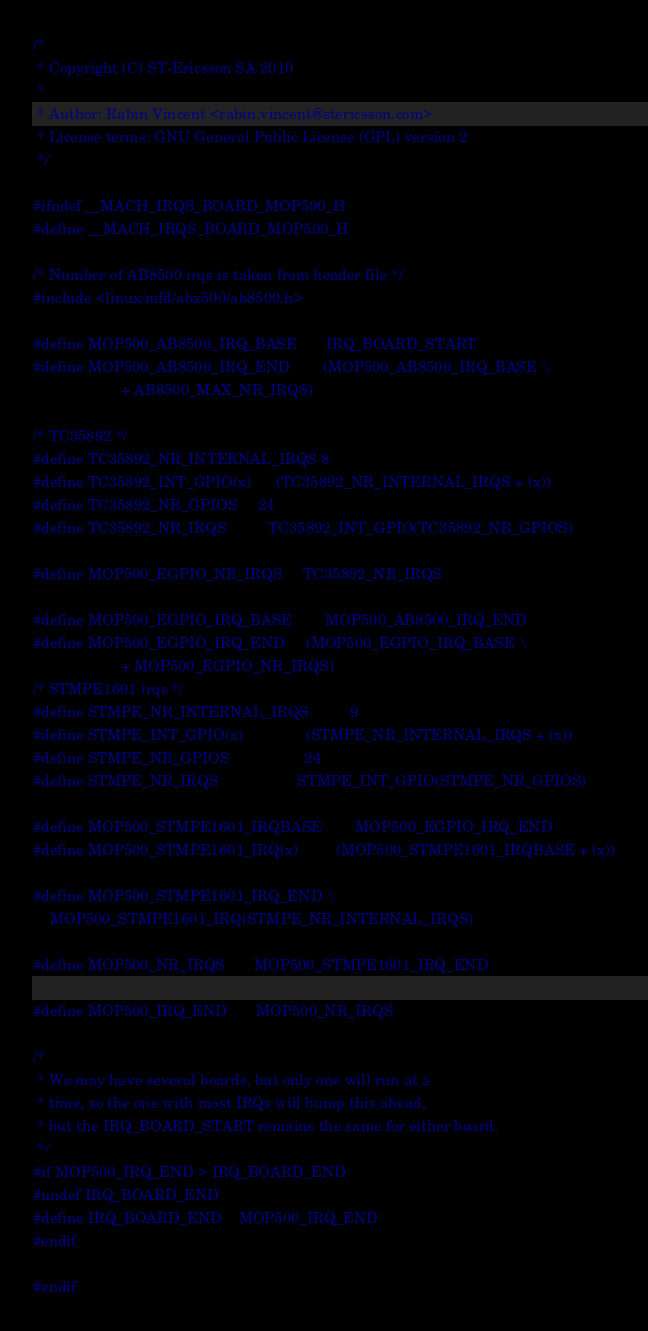Convert code to text. <code><loc_0><loc_0><loc_500><loc_500><_C_>/*
 * Copyright (C) ST-Ericsson SA 2010
 *
 * Author: Rabin Vincent <rabin.vincent@stericsson.com>
 * License terms: GNU General Public License (GPL) version 2
 */

#ifndef __MACH_IRQS_BOARD_MOP500_H
#define __MACH_IRQS_BOARD_MOP500_H

/* Number of AB8500 irqs is taken from header file */
#include <linux/mfd/abx500/ab8500.h>

#define MOP500_AB8500_IRQ_BASE		IRQ_BOARD_START
#define MOP500_AB8500_IRQ_END		(MOP500_AB8500_IRQ_BASE \
					 + AB8500_MAX_NR_IRQS)

/* TC35892 */
#define TC35892_NR_INTERNAL_IRQS	8
#define TC35892_INT_GPIO(x)		(TC35892_NR_INTERNAL_IRQS + (x))
#define TC35892_NR_GPIOS		24
#define TC35892_NR_IRQS			TC35892_INT_GPIO(TC35892_NR_GPIOS)

#define MOP500_EGPIO_NR_IRQS		TC35892_NR_IRQS

#define MOP500_EGPIO_IRQ_BASE		MOP500_AB8500_IRQ_END
#define MOP500_EGPIO_IRQ_END		(MOP500_EGPIO_IRQ_BASE \
					 + MOP500_EGPIO_NR_IRQS)
/* STMPE1601 irqs */
#define STMPE_NR_INTERNAL_IRQS          9
#define STMPE_INT_GPIO(x)               (STMPE_NR_INTERNAL_IRQS + (x))
#define STMPE_NR_GPIOS                  24
#define STMPE_NR_IRQS                   STMPE_INT_GPIO(STMPE_NR_GPIOS)

#define MOP500_STMPE1601_IRQBASE        MOP500_EGPIO_IRQ_END
#define MOP500_STMPE1601_IRQ(x)         (MOP500_STMPE1601_IRQBASE + (x))

#define MOP500_STMPE1601_IRQ_END	\
	MOP500_STMPE1601_IRQ(STMPE_NR_INTERNAL_IRQS)

#define MOP500_NR_IRQS		MOP500_STMPE1601_IRQ_END

#define MOP500_IRQ_END		MOP500_NR_IRQS

/*
 * We may have several boards, but only one will run at a
 * time, so the one with most IRQs will bump this ahead,
 * but the IRQ_BOARD_START remains the same for either board.
 */
#if MOP500_IRQ_END > IRQ_BOARD_END
#undef IRQ_BOARD_END
#define IRQ_BOARD_END	MOP500_IRQ_END
#endif

#endif
</code> 